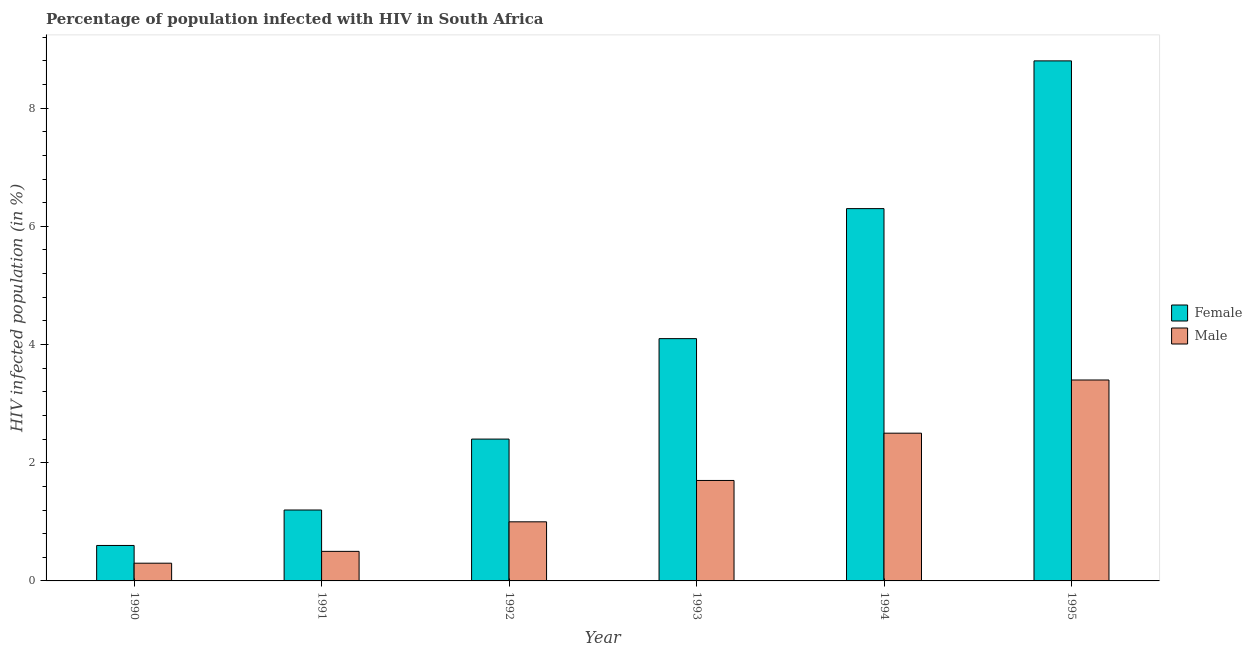How many different coloured bars are there?
Your answer should be very brief. 2. How many groups of bars are there?
Give a very brief answer. 6. Are the number of bars per tick equal to the number of legend labels?
Ensure brevity in your answer.  Yes. Are the number of bars on each tick of the X-axis equal?
Your response must be concise. Yes. How many bars are there on the 5th tick from the left?
Keep it short and to the point. 2. Across all years, what is the maximum percentage of females who are infected with hiv?
Provide a short and direct response. 8.8. In which year was the percentage of females who are infected with hiv maximum?
Your answer should be very brief. 1995. In which year was the percentage of females who are infected with hiv minimum?
Provide a short and direct response. 1990. What is the total percentage of males who are infected with hiv in the graph?
Your answer should be very brief. 9.4. In how many years, is the percentage of females who are infected with hiv greater than 8.4 %?
Ensure brevity in your answer.  1. What is the ratio of the percentage of males who are infected with hiv in 1990 to that in 1994?
Your response must be concise. 0.12. Is the percentage of females who are infected with hiv in 1992 less than that in 1995?
Offer a terse response. Yes. Is the difference between the percentage of males who are infected with hiv in 1992 and 1993 greater than the difference between the percentage of females who are infected with hiv in 1992 and 1993?
Your answer should be compact. No. What is the difference between the highest and the second highest percentage of females who are infected with hiv?
Offer a very short reply. 2.5. What is the difference between the highest and the lowest percentage of males who are infected with hiv?
Your response must be concise. 3.1. In how many years, is the percentage of females who are infected with hiv greater than the average percentage of females who are infected with hiv taken over all years?
Make the answer very short. 3. Is the sum of the percentage of females who are infected with hiv in 1990 and 1993 greater than the maximum percentage of males who are infected with hiv across all years?
Your answer should be very brief. No. What is the difference between two consecutive major ticks on the Y-axis?
Make the answer very short. 2. Are the values on the major ticks of Y-axis written in scientific E-notation?
Ensure brevity in your answer.  No. How many legend labels are there?
Offer a terse response. 2. How are the legend labels stacked?
Ensure brevity in your answer.  Vertical. What is the title of the graph?
Offer a very short reply. Percentage of population infected with HIV in South Africa. What is the label or title of the X-axis?
Provide a short and direct response. Year. What is the label or title of the Y-axis?
Give a very brief answer. HIV infected population (in %). What is the HIV infected population (in %) of Female in 1991?
Your response must be concise. 1.2. What is the HIV infected population (in %) of Male in 1991?
Make the answer very short. 0.5. What is the HIV infected population (in %) of Male in 1994?
Provide a succinct answer. 2.5. What is the HIV infected population (in %) in Female in 1995?
Make the answer very short. 8.8. Across all years, what is the maximum HIV infected population (in %) in Female?
Provide a short and direct response. 8.8. Across all years, what is the maximum HIV infected population (in %) in Male?
Ensure brevity in your answer.  3.4. What is the total HIV infected population (in %) of Female in the graph?
Provide a succinct answer. 23.4. What is the difference between the HIV infected population (in %) in Female in 1990 and that in 1993?
Make the answer very short. -3.5. What is the difference between the HIV infected population (in %) of Female in 1990 and that in 1994?
Provide a succinct answer. -5.7. What is the difference between the HIV infected population (in %) of Male in 1990 and that in 1994?
Provide a succinct answer. -2.2. What is the difference between the HIV infected population (in %) in Male in 1990 and that in 1995?
Your answer should be compact. -3.1. What is the difference between the HIV infected population (in %) of Female in 1991 and that in 1992?
Keep it short and to the point. -1.2. What is the difference between the HIV infected population (in %) of Male in 1991 and that in 1992?
Your answer should be compact. -0.5. What is the difference between the HIV infected population (in %) of Female in 1991 and that in 1993?
Keep it short and to the point. -2.9. What is the difference between the HIV infected population (in %) of Male in 1991 and that in 1993?
Your response must be concise. -1.2. What is the difference between the HIV infected population (in %) in Female in 1992 and that in 1993?
Offer a very short reply. -1.7. What is the difference between the HIV infected population (in %) in Male in 1992 and that in 1993?
Your response must be concise. -0.7. What is the difference between the HIV infected population (in %) of Female in 1992 and that in 1994?
Offer a very short reply. -3.9. What is the difference between the HIV infected population (in %) in Male in 1992 and that in 1994?
Offer a terse response. -1.5. What is the difference between the HIV infected population (in %) in Female in 1992 and that in 1995?
Provide a short and direct response. -6.4. What is the difference between the HIV infected population (in %) in Male in 1992 and that in 1995?
Make the answer very short. -2.4. What is the difference between the HIV infected population (in %) in Female in 1993 and that in 1995?
Keep it short and to the point. -4.7. What is the difference between the HIV infected population (in %) in Male in 1993 and that in 1995?
Provide a succinct answer. -1.7. What is the difference between the HIV infected population (in %) in Female in 1994 and that in 1995?
Offer a very short reply. -2.5. What is the difference between the HIV infected population (in %) in Male in 1994 and that in 1995?
Keep it short and to the point. -0.9. What is the difference between the HIV infected population (in %) of Female in 1990 and the HIV infected population (in %) of Male in 1992?
Provide a succinct answer. -0.4. What is the difference between the HIV infected population (in %) in Female in 1990 and the HIV infected population (in %) in Male in 1994?
Offer a terse response. -1.9. What is the difference between the HIV infected population (in %) of Female in 1990 and the HIV infected population (in %) of Male in 1995?
Provide a short and direct response. -2.8. What is the difference between the HIV infected population (in %) of Female in 1991 and the HIV infected population (in %) of Male in 1993?
Provide a succinct answer. -0.5. What is the difference between the HIV infected population (in %) in Female in 1991 and the HIV infected population (in %) in Male in 1994?
Ensure brevity in your answer.  -1.3. What is the difference between the HIV infected population (in %) of Female in 1992 and the HIV infected population (in %) of Male in 1993?
Your answer should be compact. 0.7. What is the difference between the HIV infected population (in %) in Female in 1994 and the HIV infected population (in %) in Male in 1995?
Your answer should be compact. 2.9. What is the average HIV infected population (in %) in Male per year?
Your response must be concise. 1.57. In the year 1992, what is the difference between the HIV infected population (in %) in Female and HIV infected population (in %) in Male?
Your answer should be compact. 1.4. In the year 1993, what is the difference between the HIV infected population (in %) in Female and HIV infected population (in %) in Male?
Provide a short and direct response. 2.4. In the year 1994, what is the difference between the HIV infected population (in %) of Female and HIV infected population (in %) of Male?
Your response must be concise. 3.8. In the year 1995, what is the difference between the HIV infected population (in %) in Female and HIV infected population (in %) in Male?
Provide a succinct answer. 5.4. What is the ratio of the HIV infected population (in %) of Male in 1990 to that in 1992?
Offer a very short reply. 0.3. What is the ratio of the HIV infected population (in %) in Female in 1990 to that in 1993?
Your answer should be compact. 0.15. What is the ratio of the HIV infected population (in %) in Male in 1990 to that in 1993?
Offer a very short reply. 0.18. What is the ratio of the HIV infected population (in %) of Female in 1990 to that in 1994?
Your response must be concise. 0.1. What is the ratio of the HIV infected population (in %) of Male in 1990 to that in 1994?
Offer a terse response. 0.12. What is the ratio of the HIV infected population (in %) of Female in 1990 to that in 1995?
Ensure brevity in your answer.  0.07. What is the ratio of the HIV infected population (in %) of Male in 1990 to that in 1995?
Give a very brief answer. 0.09. What is the ratio of the HIV infected population (in %) in Male in 1991 to that in 1992?
Provide a short and direct response. 0.5. What is the ratio of the HIV infected population (in %) in Female in 1991 to that in 1993?
Your answer should be very brief. 0.29. What is the ratio of the HIV infected population (in %) of Male in 1991 to that in 1993?
Provide a short and direct response. 0.29. What is the ratio of the HIV infected population (in %) in Female in 1991 to that in 1994?
Provide a succinct answer. 0.19. What is the ratio of the HIV infected population (in %) in Male in 1991 to that in 1994?
Provide a succinct answer. 0.2. What is the ratio of the HIV infected population (in %) in Female in 1991 to that in 1995?
Provide a short and direct response. 0.14. What is the ratio of the HIV infected population (in %) in Male in 1991 to that in 1995?
Provide a succinct answer. 0.15. What is the ratio of the HIV infected population (in %) of Female in 1992 to that in 1993?
Make the answer very short. 0.59. What is the ratio of the HIV infected population (in %) of Male in 1992 to that in 1993?
Offer a very short reply. 0.59. What is the ratio of the HIV infected population (in %) in Female in 1992 to that in 1994?
Offer a very short reply. 0.38. What is the ratio of the HIV infected population (in %) in Male in 1992 to that in 1994?
Offer a very short reply. 0.4. What is the ratio of the HIV infected population (in %) of Female in 1992 to that in 1995?
Provide a succinct answer. 0.27. What is the ratio of the HIV infected population (in %) in Male in 1992 to that in 1995?
Ensure brevity in your answer.  0.29. What is the ratio of the HIV infected population (in %) in Female in 1993 to that in 1994?
Keep it short and to the point. 0.65. What is the ratio of the HIV infected population (in %) of Male in 1993 to that in 1994?
Keep it short and to the point. 0.68. What is the ratio of the HIV infected population (in %) of Female in 1993 to that in 1995?
Ensure brevity in your answer.  0.47. What is the ratio of the HIV infected population (in %) of Male in 1993 to that in 1995?
Offer a very short reply. 0.5. What is the ratio of the HIV infected population (in %) of Female in 1994 to that in 1995?
Make the answer very short. 0.72. What is the ratio of the HIV infected population (in %) of Male in 1994 to that in 1995?
Ensure brevity in your answer.  0.74. What is the difference between the highest and the second highest HIV infected population (in %) in Female?
Provide a short and direct response. 2.5. What is the difference between the highest and the lowest HIV infected population (in %) of Female?
Give a very brief answer. 8.2. What is the difference between the highest and the lowest HIV infected population (in %) in Male?
Offer a terse response. 3.1. 